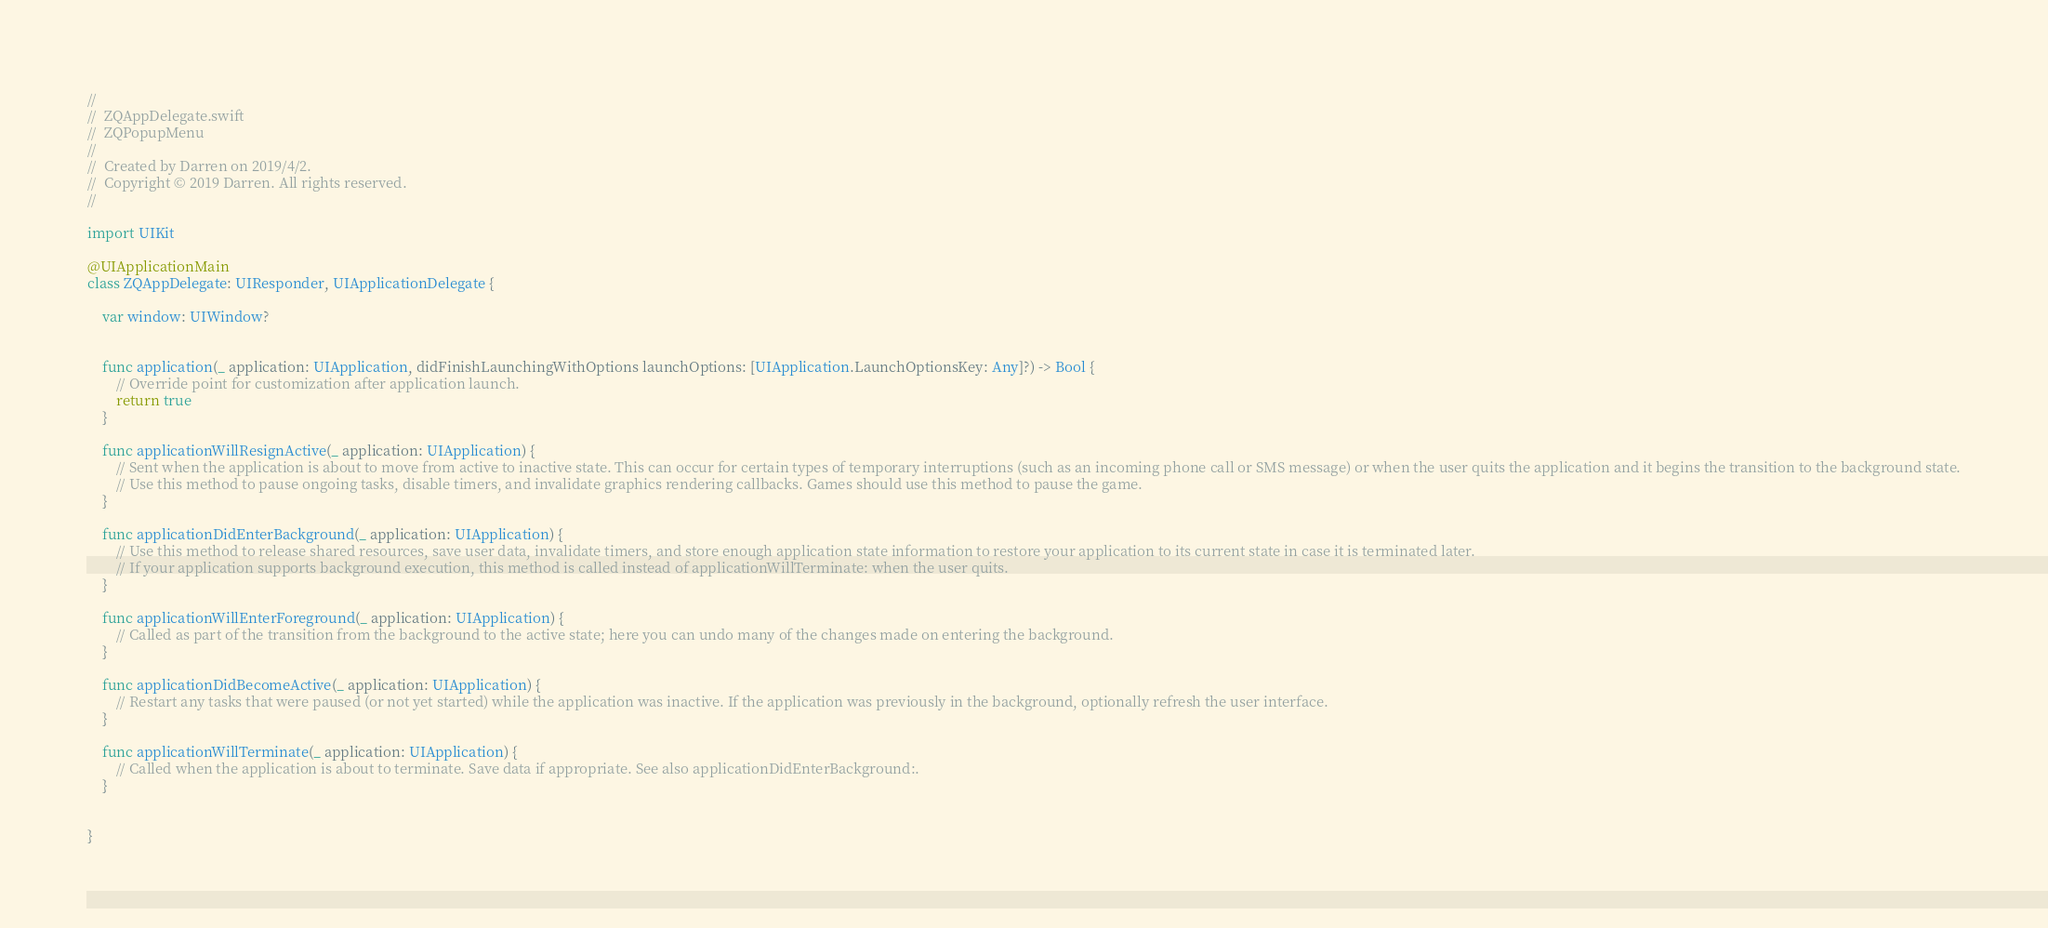Convert code to text. <code><loc_0><loc_0><loc_500><loc_500><_Swift_>//
//  ZQAppDelegate.swift
//  ZQPopupMenu
//
//  Created by Darren on 2019/4/2.
//  Copyright © 2019 Darren. All rights reserved.
//

import UIKit

@UIApplicationMain
class ZQAppDelegate: UIResponder, UIApplicationDelegate {

    var window: UIWindow?


    func application(_ application: UIApplication, didFinishLaunchingWithOptions launchOptions: [UIApplication.LaunchOptionsKey: Any]?) -> Bool {
        // Override point for customization after application launch.
        return true
    }

    func applicationWillResignActive(_ application: UIApplication) {
        // Sent when the application is about to move from active to inactive state. This can occur for certain types of temporary interruptions (such as an incoming phone call or SMS message) or when the user quits the application and it begins the transition to the background state.
        // Use this method to pause ongoing tasks, disable timers, and invalidate graphics rendering callbacks. Games should use this method to pause the game.
    }

    func applicationDidEnterBackground(_ application: UIApplication) {
        // Use this method to release shared resources, save user data, invalidate timers, and store enough application state information to restore your application to its current state in case it is terminated later.
        // If your application supports background execution, this method is called instead of applicationWillTerminate: when the user quits.
    }

    func applicationWillEnterForeground(_ application: UIApplication) {
        // Called as part of the transition from the background to the active state; here you can undo many of the changes made on entering the background.
    }

    func applicationDidBecomeActive(_ application: UIApplication) {
        // Restart any tasks that were paused (or not yet started) while the application was inactive. If the application was previously in the background, optionally refresh the user interface.
    }

    func applicationWillTerminate(_ application: UIApplication) {
        // Called when the application is about to terminate. Save data if appropriate. See also applicationDidEnterBackground:.
    }


}

</code> 